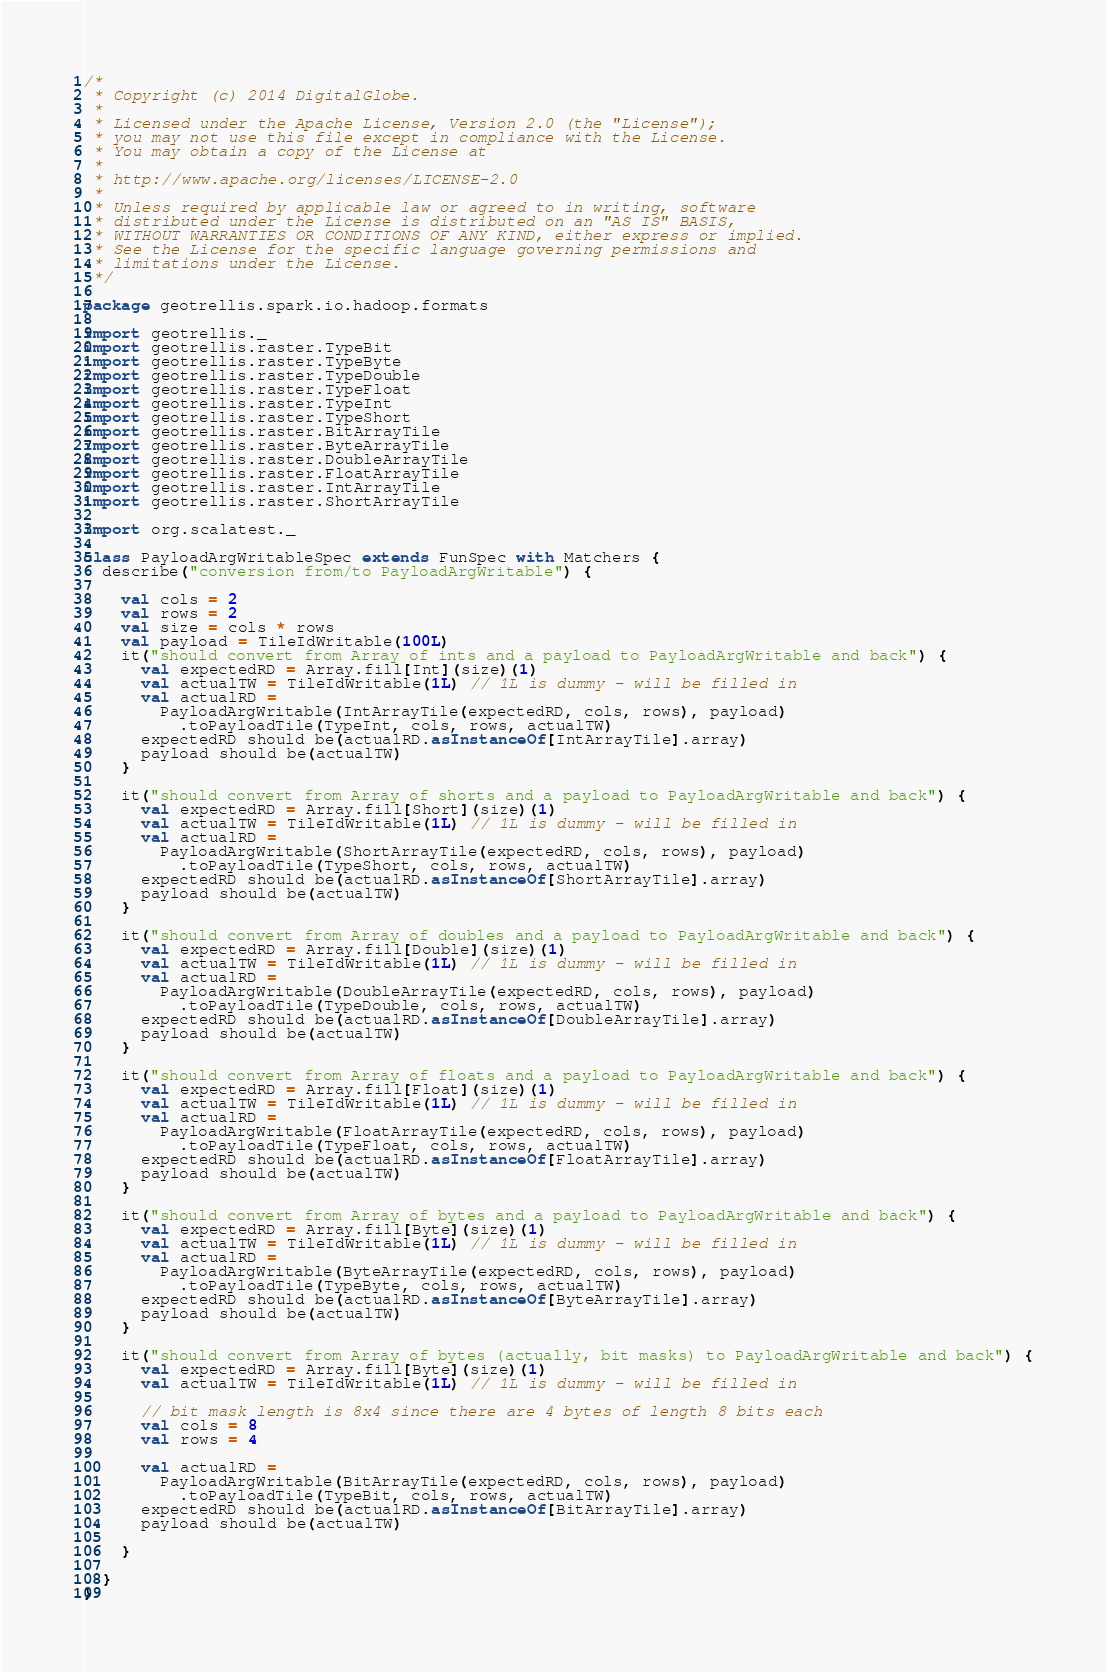Convert code to text. <code><loc_0><loc_0><loc_500><loc_500><_Scala_>/*
 * Copyright (c) 2014 DigitalGlobe.
 * 
 * Licensed under the Apache License, Version 2.0 (the "License");
 * you may not use this file except in compliance with the License.
 * You may obtain a copy of the License at
 * 
 * http://www.apache.org/licenses/LICENSE-2.0
 * 
 * Unless required by applicable law or agreed to in writing, software
 * distributed under the License is distributed on an "AS IS" BASIS,
 * WITHOUT WARRANTIES OR CONDITIONS OF ANY KIND, either express or implied.
 * See the License for the specific language governing permissions and
 * limitations under the License.
 */

package geotrellis.spark.io.hadoop.formats

import geotrellis._
import geotrellis.raster.TypeBit
import geotrellis.raster.TypeByte
import geotrellis.raster.TypeDouble
import geotrellis.raster.TypeFloat
import geotrellis.raster.TypeInt
import geotrellis.raster.TypeShort
import geotrellis.raster.BitArrayTile
import geotrellis.raster.ByteArrayTile
import geotrellis.raster.DoubleArrayTile
import geotrellis.raster.FloatArrayTile
import geotrellis.raster.IntArrayTile
import geotrellis.raster.ShortArrayTile

import org.scalatest._

class PayloadArgWritableSpec extends FunSpec with Matchers {
  describe("conversion from/to PayloadArgWritable") {

    val cols = 2
    val rows = 2
    val size = cols * rows
    val payload = TileIdWritable(100L)
    it("should convert from Array of ints and a payload to PayloadArgWritable and back") {
      val expectedRD = Array.fill[Int](size)(1)
      val actualTW = TileIdWritable(1L) // 1L is dummy - will be filled in
      val actualRD =
        PayloadArgWritable(IntArrayTile(expectedRD, cols, rows), payload)
          .toPayloadTile(TypeInt, cols, rows, actualTW)
      expectedRD should be(actualRD.asInstanceOf[IntArrayTile].array)
      payload should be(actualTW)
    }

    it("should convert from Array of shorts and a payload to PayloadArgWritable and back") {
      val expectedRD = Array.fill[Short](size)(1)
      val actualTW = TileIdWritable(1L) // 1L is dummy - will be filled in
      val actualRD =
        PayloadArgWritable(ShortArrayTile(expectedRD, cols, rows), payload)
          .toPayloadTile(TypeShort, cols, rows, actualTW)
      expectedRD should be(actualRD.asInstanceOf[ShortArrayTile].array)
      payload should be(actualTW)
    }

    it("should convert from Array of doubles and a payload to PayloadArgWritable and back") {
      val expectedRD = Array.fill[Double](size)(1)
      val actualTW = TileIdWritable(1L) // 1L is dummy - will be filled in
      val actualRD =
        PayloadArgWritable(DoubleArrayTile(expectedRD, cols, rows), payload)
          .toPayloadTile(TypeDouble, cols, rows, actualTW)
      expectedRD should be(actualRD.asInstanceOf[DoubleArrayTile].array)
      payload should be(actualTW)
    }

    it("should convert from Array of floats and a payload to PayloadArgWritable and back") {
      val expectedRD = Array.fill[Float](size)(1)
      val actualTW = TileIdWritable(1L) // 1L is dummy - will be filled in
      val actualRD =
        PayloadArgWritable(FloatArrayTile(expectedRD, cols, rows), payload)
          .toPayloadTile(TypeFloat, cols, rows, actualTW)
      expectedRD should be(actualRD.asInstanceOf[FloatArrayTile].array)
      payload should be(actualTW)
    }

    it("should convert from Array of bytes and a payload to PayloadArgWritable and back") {
      val expectedRD = Array.fill[Byte](size)(1)
      val actualTW = TileIdWritable(1L) // 1L is dummy - will be filled in
      val actualRD =
        PayloadArgWritable(ByteArrayTile(expectedRD, cols, rows), payload)
          .toPayloadTile(TypeByte, cols, rows, actualTW)
      expectedRD should be(actualRD.asInstanceOf[ByteArrayTile].array)
      payload should be(actualTW)
    }

    it("should convert from Array of bytes (actually, bit masks) to PayloadArgWritable and back") {
      val expectedRD = Array.fill[Byte](size)(1)
      val actualTW = TileIdWritable(1L) // 1L is dummy - will be filled in

      // bit mask length is 8x4 since there are 4 bytes of length 8 bits each
      val cols = 8
      val rows = 4

      val actualRD =
        PayloadArgWritable(BitArrayTile(expectedRD, cols, rows), payload)
          .toPayloadTile(TypeBit, cols, rows, actualTW)
      expectedRD should be(actualRD.asInstanceOf[BitArrayTile].array)
      payload should be(actualTW)

    }

  }
}
</code> 